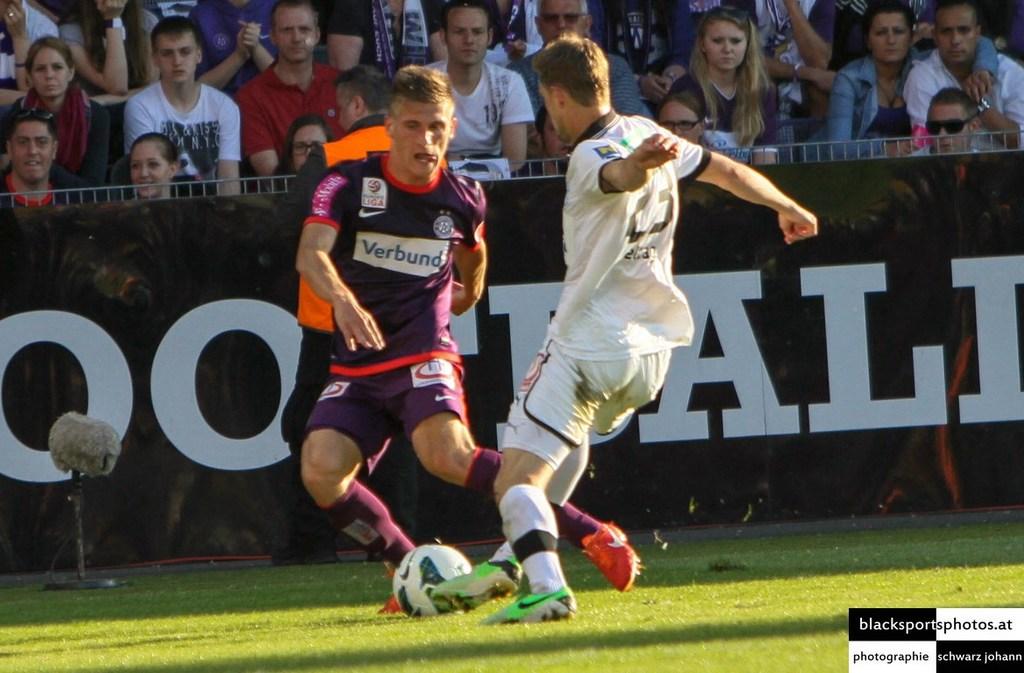What does the text displayed in the front of the purple shirt say?
Keep it short and to the point. Verbund. What is the jersey number of the player in white?
Offer a very short reply. 23. 